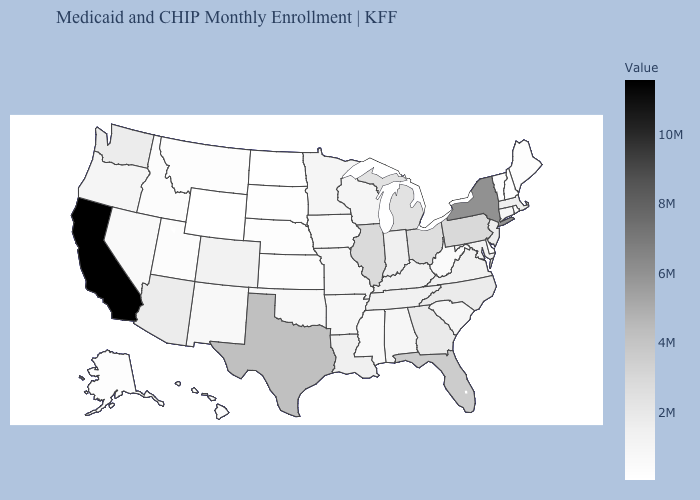Which states hav the highest value in the South?
Concise answer only. Texas. Does Massachusetts have the highest value in the USA?
Write a very short answer. No. Which states have the lowest value in the USA?
Write a very short answer. Wyoming. Among the states that border New Jersey , which have the highest value?
Be succinct. New York. Which states have the lowest value in the USA?
Quick response, please. Wyoming. Does Oklahoma have the lowest value in the USA?
Short answer required. No. Does the map have missing data?
Answer briefly. No. 